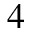Convert formula to latex. <formula><loc_0><loc_0><loc_500><loc_500>^ { 4 }</formula> 